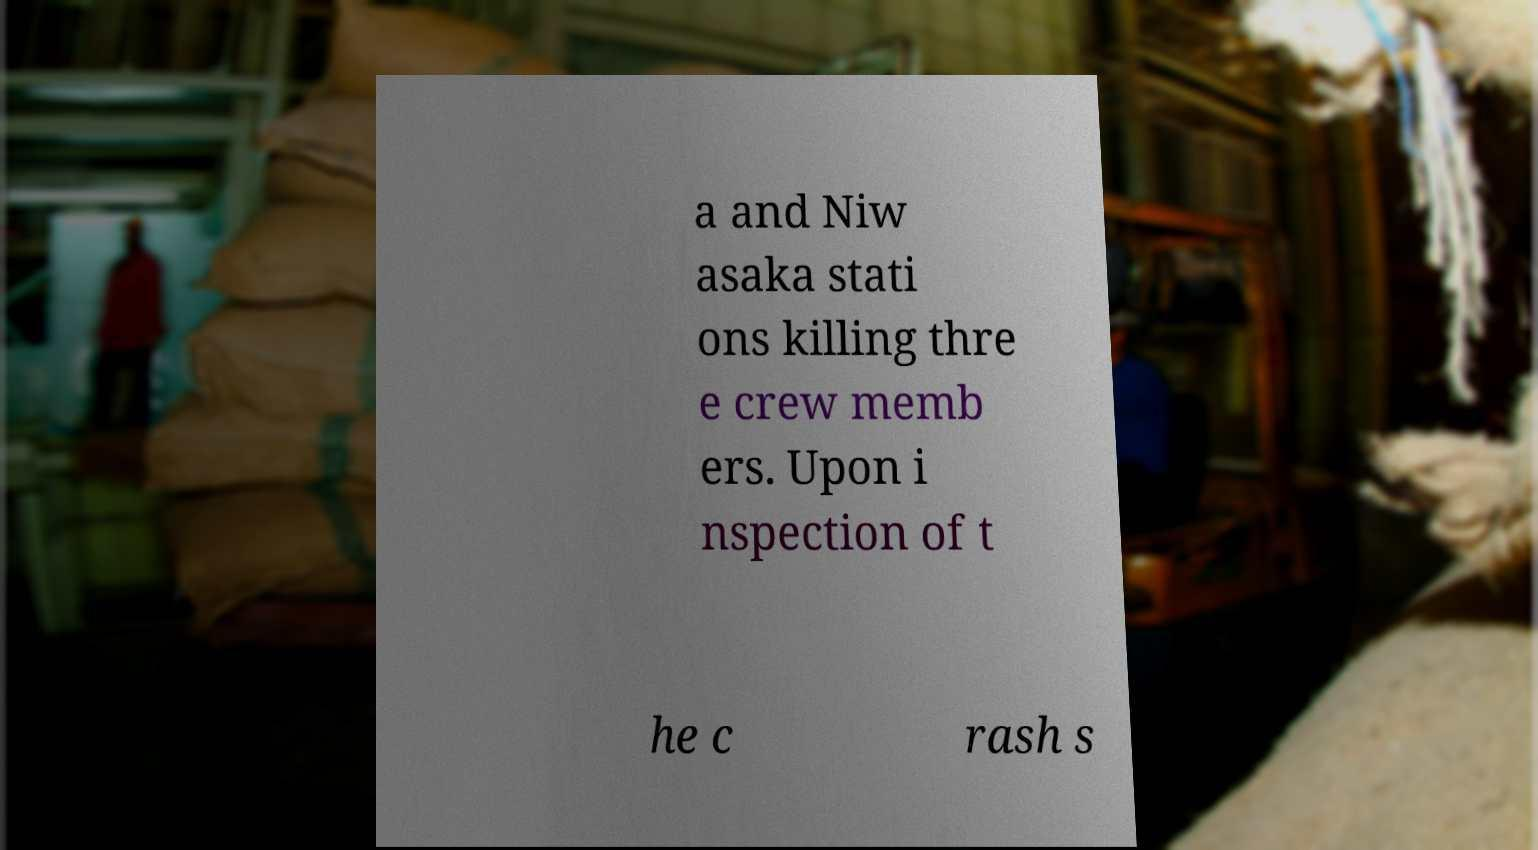Can you read and provide the text displayed in the image?This photo seems to have some interesting text. Can you extract and type it out for me? a and Niw asaka stati ons killing thre e crew memb ers. Upon i nspection of t he c rash s 